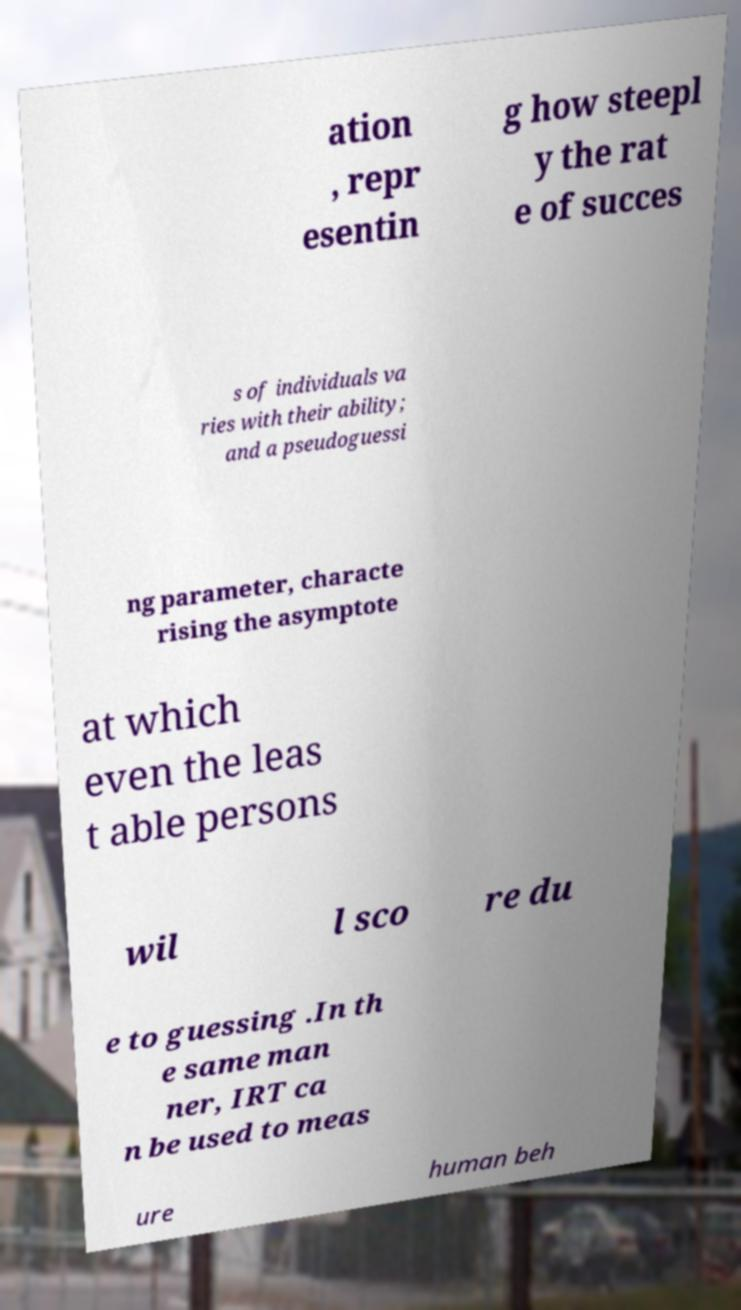Could you assist in decoding the text presented in this image and type it out clearly? ation , repr esentin g how steepl y the rat e of succes s of individuals va ries with their ability; and a pseudoguessi ng parameter, characte rising the asymptote at which even the leas t able persons wil l sco re du e to guessing .In th e same man ner, IRT ca n be used to meas ure human beh 